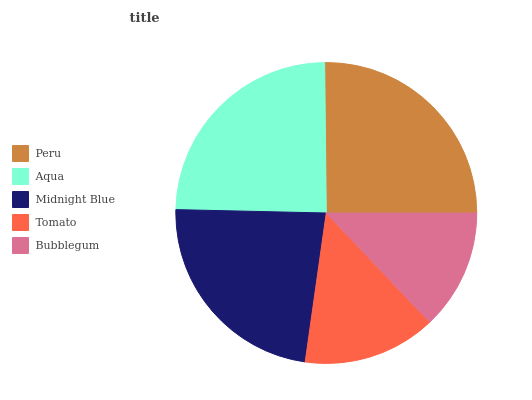Is Bubblegum the minimum?
Answer yes or no. Yes. Is Peru the maximum?
Answer yes or no. Yes. Is Aqua the minimum?
Answer yes or no. No. Is Aqua the maximum?
Answer yes or no. No. Is Peru greater than Aqua?
Answer yes or no. Yes. Is Aqua less than Peru?
Answer yes or no. Yes. Is Aqua greater than Peru?
Answer yes or no. No. Is Peru less than Aqua?
Answer yes or no. No. Is Midnight Blue the high median?
Answer yes or no. Yes. Is Midnight Blue the low median?
Answer yes or no. Yes. Is Tomato the high median?
Answer yes or no. No. Is Peru the low median?
Answer yes or no. No. 